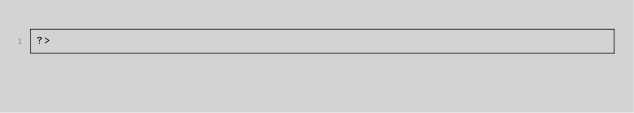<code> <loc_0><loc_0><loc_500><loc_500><_PHP_>?>
</code> 